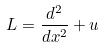Convert formula to latex. <formula><loc_0><loc_0><loc_500><loc_500>L = \frac { d ^ { 2 } } { d x ^ { 2 } } + u</formula> 